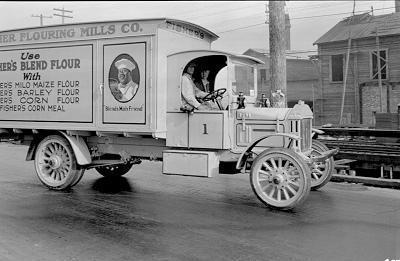How many wheels does the truck have?
Give a very brief answer. 4. How many people are riding in the truck?
Give a very brief answer. 2. How many apples in the triangle?
Give a very brief answer. 0. 